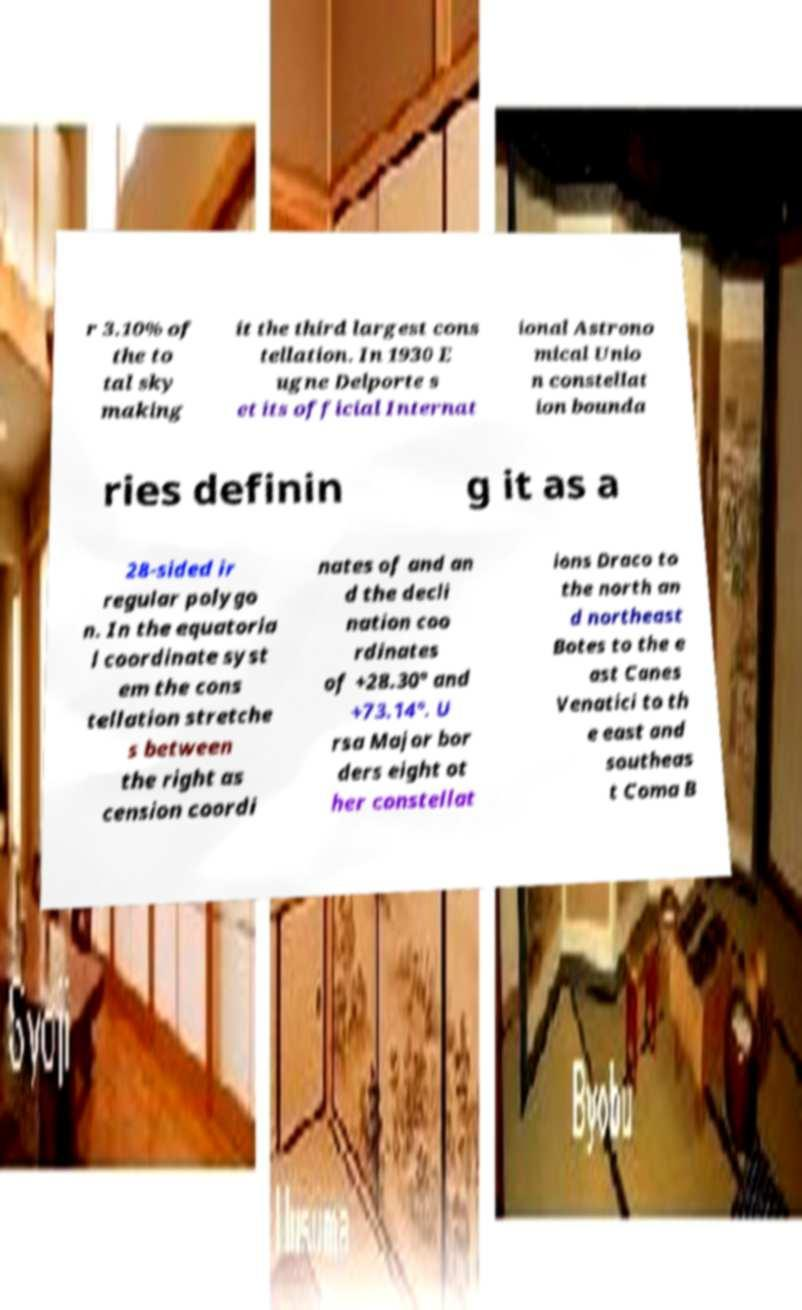I need the written content from this picture converted into text. Can you do that? r 3.10% of the to tal sky making it the third largest cons tellation. In 1930 E ugne Delporte s et its official Internat ional Astrono mical Unio n constellat ion bounda ries definin g it as a 28-sided ir regular polygo n. In the equatoria l coordinate syst em the cons tellation stretche s between the right as cension coordi nates of and an d the decli nation coo rdinates of +28.30° and +73.14°. U rsa Major bor ders eight ot her constellat ions Draco to the north an d northeast Botes to the e ast Canes Venatici to th e east and southeas t Coma B 